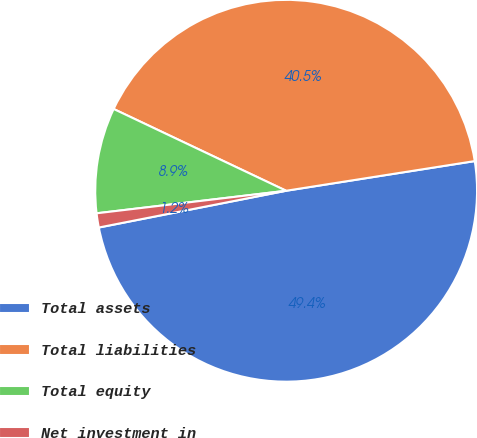Convert chart to OTSL. <chart><loc_0><loc_0><loc_500><loc_500><pie_chart><fcel>Total assets<fcel>Total liabilities<fcel>Total equity<fcel>Net investment in<nl><fcel>49.4%<fcel>40.47%<fcel>8.93%<fcel>1.2%<nl></chart> 